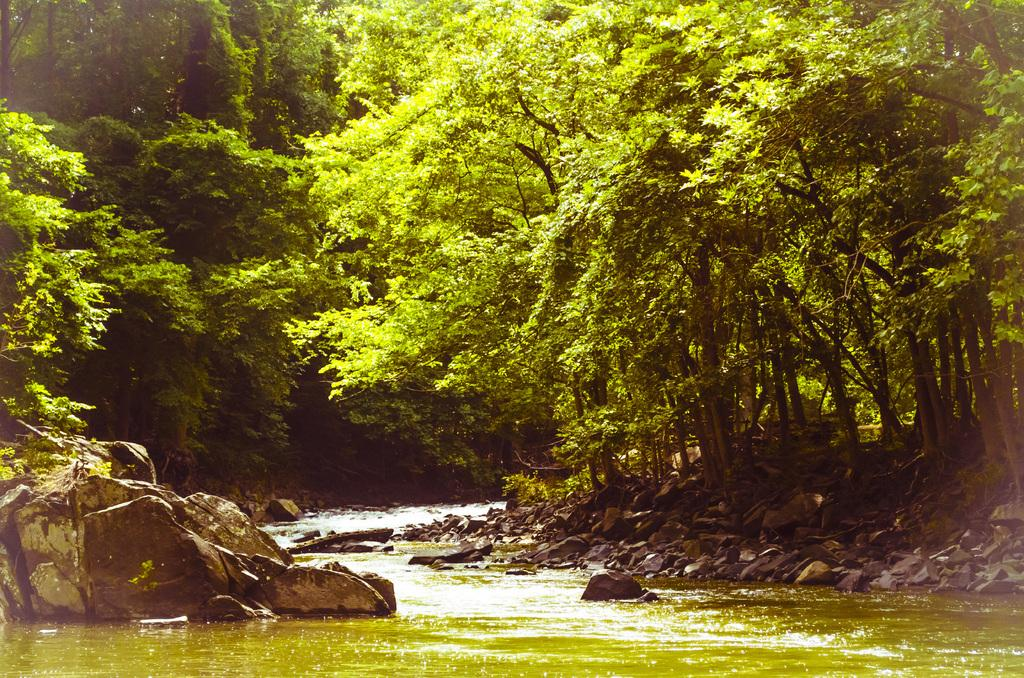What is the main subject in the center of the image? There is water in the center of the image. What can be seen in the background of the image? There is a group of trees and rocks in the background. How many oranges are visible in the image? There are no oranges present in the image. What is the size of the pigs in the image? There are no pigs present in the image. 